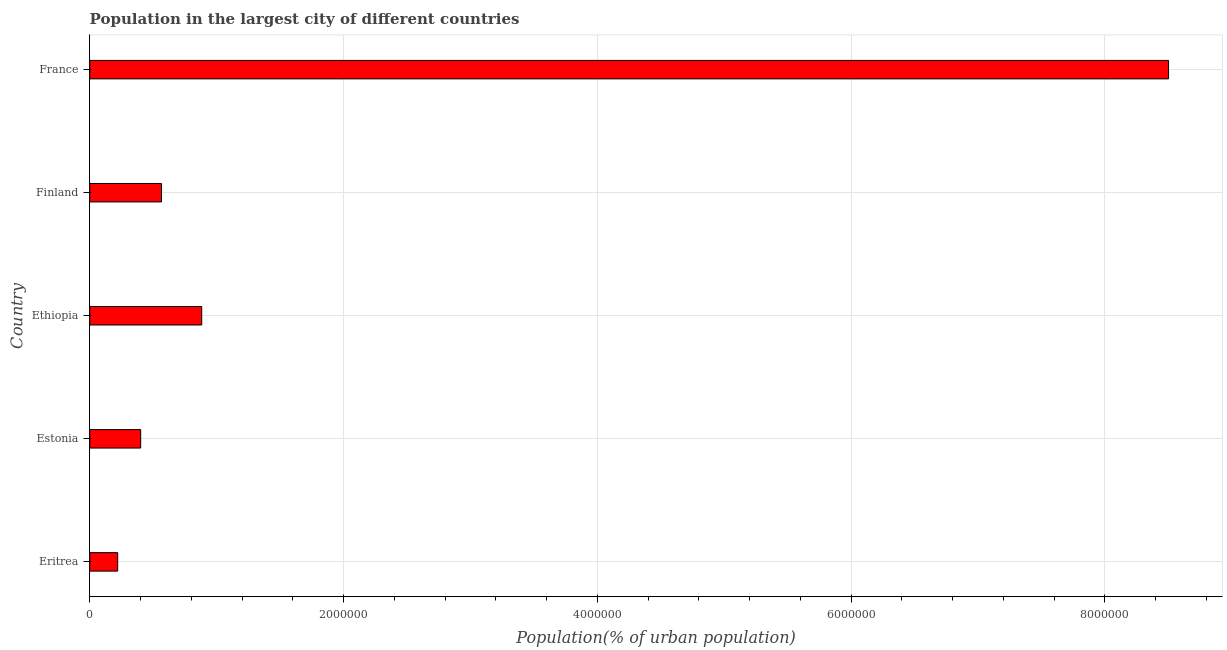Does the graph contain grids?
Ensure brevity in your answer.  Yes. What is the title of the graph?
Offer a very short reply. Population in the largest city of different countries. What is the label or title of the X-axis?
Offer a terse response. Population(% of urban population). What is the label or title of the Y-axis?
Offer a terse response. Country. What is the population in largest city in France?
Your answer should be very brief. 8.50e+06. Across all countries, what is the maximum population in largest city?
Your answer should be very brief. 8.50e+06. Across all countries, what is the minimum population in largest city?
Give a very brief answer. 2.20e+05. In which country was the population in largest city maximum?
Your response must be concise. France. In which country was the population in largest city minimum?
Make the answer very short. Eritrea. What is the sum of the population in largest city?
Offer a terse response. 1.06e+07. What is the difference between the population in largest city in Eritrea and France?
Make the answer very short. -8.28e+06. What is the average population in largest city per country?
Give a very brief answer. 2.11e+06. What is the median population in largest city?
Provide a short and direct response. 5.65e+05. What is the ratio of the population in largest city in Ethiopia to that in France?
Offer a terse response. 0.1. Is the population in largest city in Eritrea less than that in Ethiopia?
Offer a very short reply. Yes. Is the difference between the population in largest city in Ethiopia and Finland greater than the difference between any two countries?
Offer a very short reply. No. What is the difference between the highest and the second highest population in largest city?
Your response must be concise. 7.62e+06. What is the difference between the highest and the lowest population in largest city?
Offer a very short reply. 8.28e+06. How many bars are there?
Your response must be concise. 5. Are all the bars in the graph horizontal?
Offer a terse response. Yes. What is the Population(% of urban population) of Eritrea?
Offer a terse response. 2.20e+05. What is the Population(% of urban population) of Estonia?
Make the answer very short. 4.01e+05. What is the Population(% of urban population) in Ethiopia?
Your answer should be very brief. 8.83e+05. What is the Population(% of urban population) of Finland?
Give a very brief answer. 5.65e+05. What is the Population(% of urban population) of France?
Ensure brevity in your answer.  8.50e+06. What is the difference between the Population(% of urban population) in Eritrea and Estonia?
Your answer should be very brief. -1.81e+05. What is the difference between the Population(% of urban population) in Eritrea and Ethiopia?
Make the answer very short. -6.62e+05. What is the difference between the Population(% of urban population) in Eritrea and Finland?
Provide a short and direct response. -3.45e+05. What is the difference between the Population(% of urban population) in Eritrea and France?
Ensure brevity in your answer.  -8.28e+06. What is the difference between the Population(% of urban population) in Estonia and Ethiopia?
Provide a succinct answer. -4.81e+05. What is the difference between the Population(% of urban population) in Estonia and Finland?
Provide a short and direct response. -1.64e+05. What is the difference between the Population(% of urban population) in Estonia and France?
Keep it short and to the point. -8.10e+06. What is the difference between the Population(% of urban population) in Ethiopia and Finland?
Provide a succinct answer. 3.17e+05. What is the difference between the Population(% of urban population) in Ethiopia and France?
Ensure brevity in your answer.  -7.62e+06. What is the difference between the Population(% of urban population) in Finland and France?
Provide a succinct answer. -7.94e+06. What is the ratio of the Population(% of urban population) in Eritrea to that in Estonia?
Provide a short and direct response. 0.55. What is the ratio of the Population(% of urban population) in Eritrea to that in Finland?
Provide a succinct answer. 0.39. What is the ratio of the Population(% of urban population) in Eritrea to that in France?
Give a very brief answer. 0.03. What is the ratio of the Population(% of urban population) in Estonia to that in Ethiopia?
Your response must be concise. 0.46. What is the ratio of the Population(% of urban population) in Estonia to that in Finland?
Offer a terse response. 0.71. What is the ratio of the Population(% of urban population) in Estonia to that in France?
Offer a terse response. 0.05. What is the ratio of the Population(% of urban population) in Ethiopia to that in Finland?
Your answer should be compact. 1.56. What is the ratio of the Population(% of urban population) in Ethiopia to that in France?
Offer a terse response. 0.1. What is the ratio of the Population(% of urban population) in Finland to that in France?
Provide a succinct answer. 0.07. 